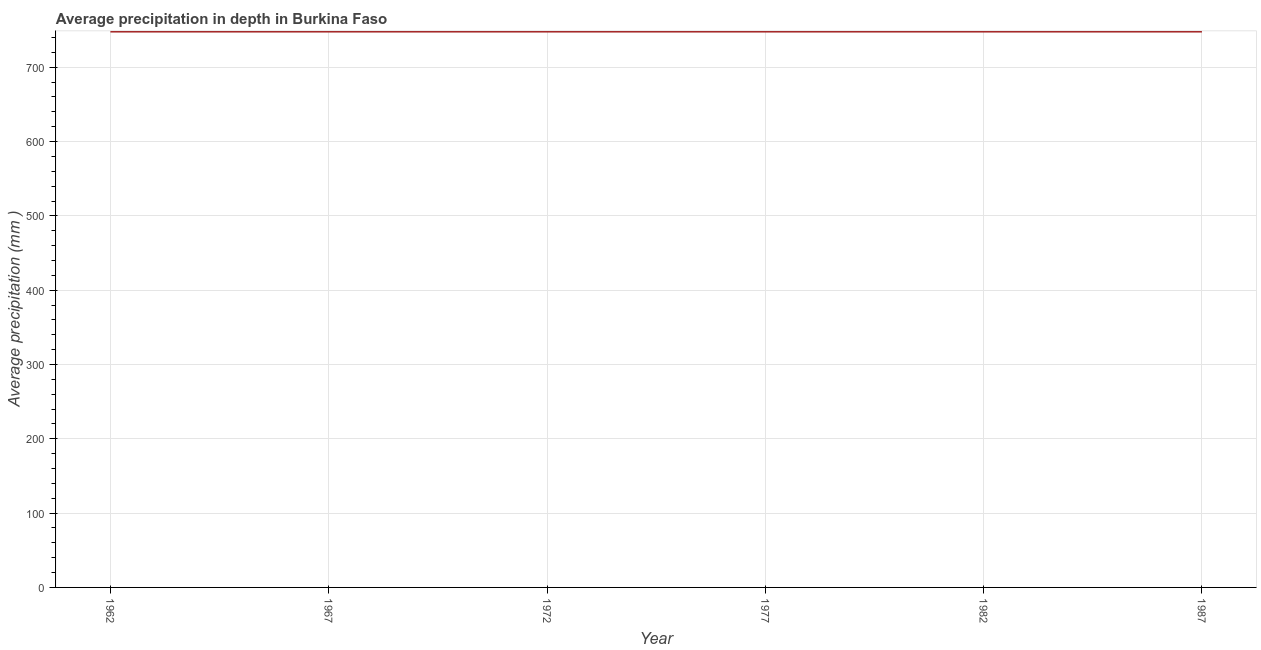What is the average precipitation in depth in 1967?
Offer a very short reply. 748. Across all years, what is the maximum average precipitation in depth?
Your answer should be compact. 748. Across all years, what is the minimum average precipitation in depth?
Give a very brief answer. 748. In which year was the average precipitation in depth minimum?
Give a very brief answer. 1962. What is the sum of the average precipitation in depth?
Offer a very short reply. 4488. What is the difference between the average precipitation in depth in 1962 and 1972?
Provide a succinct answer. 0. What is the average average precipitation in depth per year?
Offer a very short reply. 748. What is the median average precipitation in depth?
Give a very brief answer. 748. In how many years, is the average precipitation in depth greater than 460 mm?
Your answer should be very brief. 6. Do a majority of the years between 1977 and 1962 (inclusive) have average precipitation in depth greater than 620 mm?
Keep it short and to the point. Yes. What is the difference between the highest and the lowest average precipitation in depth?
Your answer should be very brief. 0. In how many years, is the average precipitation in depth greater than the average average precipitation in depth taken over all years?
Your answer should be very brief. 0. How many lines are there?
Provide a short and direct response. 1. How many years are there in the graph?
Ensure brevity in your answer.  6. Are the values on the major ticks of Y-axis written in scientific E-notation?
Offer a terse response. No. Does the graph contain any zero values?
Your response must be concise. No. Does the graph contain grids?
Offer a terse response. Yes. What is the title of the graph?
Your answer should be compact. Average precipitation in depth in Burkina Faso. What is the label or title of the Y-axis?
Offer a very short reply. Average precipitation (mm ). What is the Average precipitation (mm ) in 1962?
Ensure brevity in your answer.  748. What is the Average precipitation (mm ) in 1967?
Provide a succinct answer. 748. What is the Average precipitation (mm ) in 1972?
Keep it short and to the point. 748. What is the Average precipitation (mm ) of 1977?
Offer a terse response. 748. What is the Average precipitation (mm ) in 1982?
Your answer should be compact. 748. What is the Average precipitation (mm ) in 1987?
Offer a terse response. 748. What is the difference between the Average precipitation (mm ) in 1962 and 1982?
Your response must be concise. 0. What is the difference between the Average precipitation (mm ) in 1967 and 1972?
Provide a short and direct response. 0. What is the difference between the Average precipitation (mm ) in 1967 and 1982?
Provide a short and direct response. 0. What is the difference between the Average precipitation (mm ) in 1967 and 1987?
Offer a very short reply. 0. What is the difference between the Average precipitation (mm ) in 1972 and 1977?
Make the answer very short. 0. What is the difference between the Average precipitation (mm ) in 1972 and 1982?
Make the answer very short. 0. What is the difference between the Average precipitation (mm ) in 1972 and 1987?
Offer a very short reply. 0. What is the difference between the Average precipitation (mm ) in 1982 and 1987?
Offer a very short reply. 0. What is the ratio of the Average precipitation (mm ) in 1962 to that in 1967?
Provide a succinct answer. 1. What is the ratio of the Average precipitation (mm ) in 1962 to that in 1972?
Your answer should be compact. 1. What is the ratio of the Average precipitation (mm ) in 1962 to that in 1977?
Your response must be concise. 1. What is the ratio of the Average precipitation (mm ) in 1972 to that in 1977?
Make the answer very short. 1. What is the ratio of the Average precipitation (mm ) in 1972 to that in 1982?
Offer a terse response. 1. What is the ratio of the Average precipitation (mm ) in 1972 to that in 1987?
Your answer should be very brief. 1. What is the ratio of the Average precipitation (mm ) in 1977 to that in 1987?
Make the answer very short. 1. 